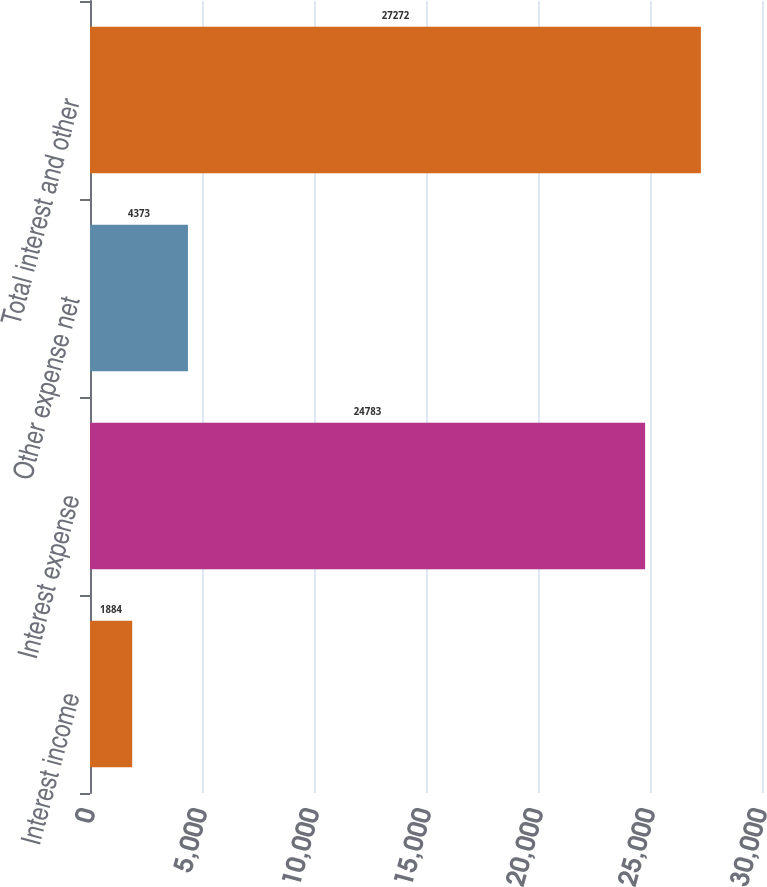<chart> <loc_0><loc_0><loc_500><loc_500><bar_chart><fcel>Interest income<fcel>Interest expense<fcel>Other expense net<fcel>Total interest and other<nl><fcel>1884<fcel>24783<fcel>4373<fcel>27272<nl></chart> 